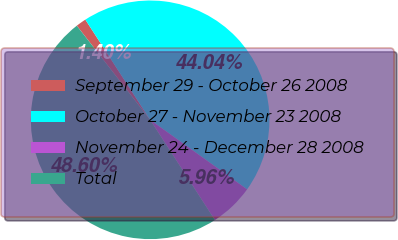Convert chart. <chart><loc_0><loc_0><loc_500><loc_500><pie_chart><fcel>September 29 - October 26 2008<fcel>October 27 - November 23 2008<fcel>November 24 - December 28 2008<fcel>Total<nl><fcel>1.4%<fcel>44.04%<fcel>5.96%<fcel>48.6%<nl></chart> 